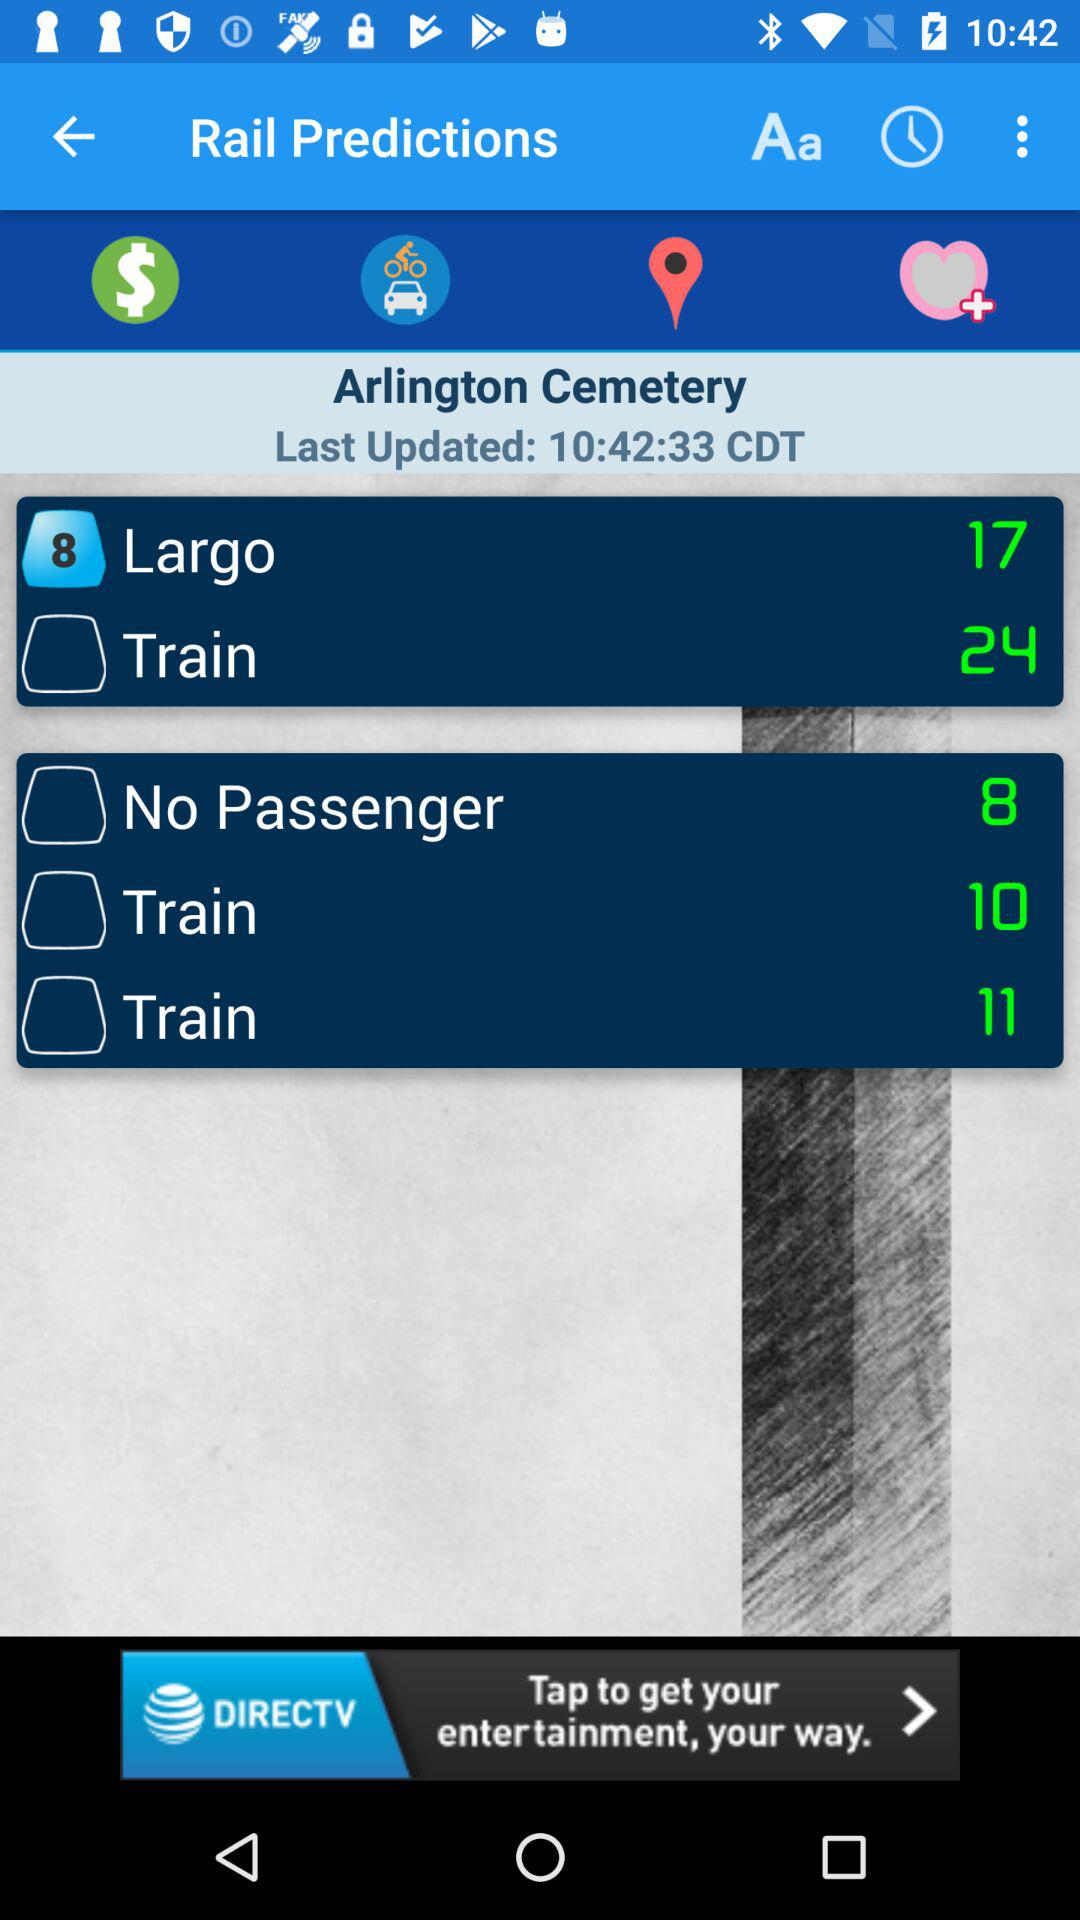When was the rail prediction last updated? The rail prediction was last updated at 10:42:33 CDT. 